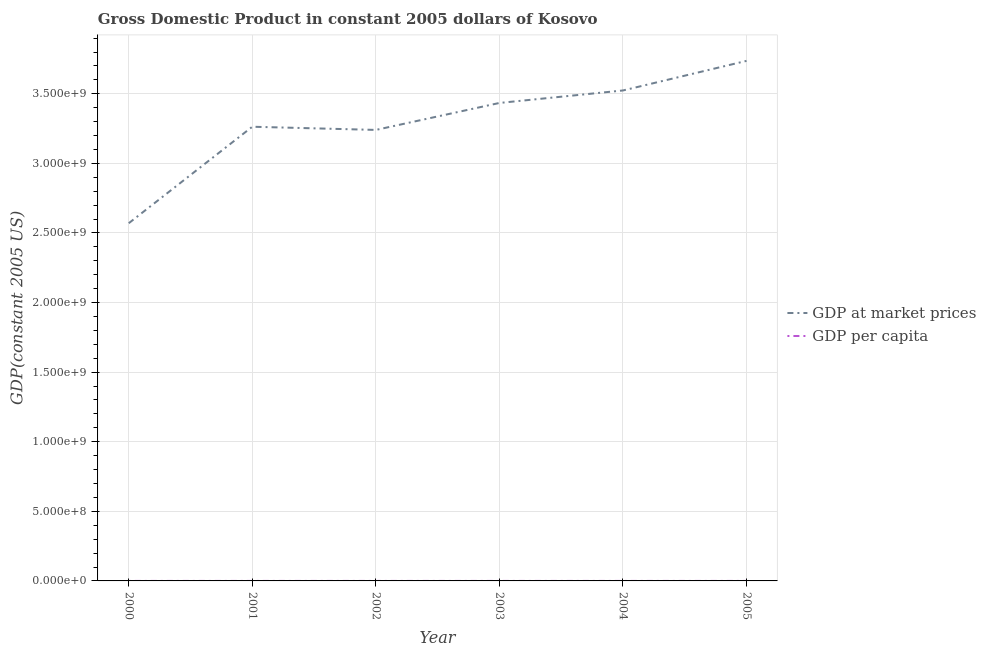How many different coloured lines are there?
Your answer should be very brief. 2. Does the line corresponding to gdp per capita intersect with the line corresponding to gdp at market prices?
Give a very brief answer. No. Is the number of lines equal to the number of legend labels?
Your answer should be very brief. Yes. What is the gdp per capita in 2003?
Keep it short and to the point. 2016.06. Across all years, what is the maximum gdp per capita?
Your response must be concise. 2190.55. Across all years, what is the minimum gdp per capita?
Provide a succinct answer. 1511.83. In which year was the gdp per capita maximum?
Make the answer very short. 2005. What is the total gdp per capita in the graph?
Ensure brevity in your answer.  1.16e+04. What is the difference between the gdp per capita in 2003 and that in 2004?
Your response must be concise. -51.26. What is the difference between the gdp at market prices in 2003 and the gdp per capita in 2000?
Your answer should be compact. 3.43e+09. What is the average gdp at market prices per year?
Offer a very short reply. 3.29e+09. In the year 2004, what is the difference between the gdp at market prices and gdp per capita?
Provide a succinct answer. 3.52e+09. What is the ratio of the gdp per capita in 2000 to that in 2005?
Ensure brevity in your answer.  0.69. Is the difference between the gdp at market prices in 2000 and 2005 greater than the difference between the gdp per capita in 2000 and 2005?
Keep it short and to the point. No. What is the difference between the highest and the second highest gdp at market prices?
Your answer should be compact. 2.13e+08. What is the difference between the highest and the lowest gdp at market prices?
Provide a succinct answer. 1.17e+09. Does the gdp at market prices monotonically increase over the years?
Make the answer very short. No. Is the gdp per capita strictly greater than the gdp at market prices over the years?
Your answer should be very brief. No. How many lines are there?
Give a very brief answer. 2. How many years are there in the graph?
Your response must be concise. 6. What is the difference between two consecutive major ticks on the Y-axis?
Your response must be concise. 5.00e+08. Does the graph contain any zero values?
Ensure brevity in your answer.  No. Does the graph contain grids?
Ensure brevity in your answer.  Yes. Where does the legend appear in the graph?
Offer a terse response. Center right. How are the legend labels stacked?
Your response must be concise. Vertical. What is the title of the graph?
Provide a succinct answer. Gross Domestic Product in constant 2005 dollars of Kosovo. Does "Register a business" appear as one of the legend labels in the graph?
Your response must be concise. No. What is the label or title of the X-axis?
Give a very brief answer. Year. What is the label or title of the Y-axis?
Provide a short and direct response. GDP(constant 2005 US). What is the GDP(constant 2005 US) of GDP at market prices in 2000?
Provide a succinct answer. 2.57e+09. What is the GDP(constant 2005 US) of GDP per capita in 2000?
Keep it short and to the point. 1511.83. What is the GDP(constant 2005 US) in GDP at market prices in 2001?
Give a very brief answer. 3.26e+09. What is the GDP(constant 2005 US) in GDP per capita in 2001?
Provide a succinct answer. 1918.33. What is the GDP(constant 2005 US) in GDP at market prices in 2002?
Your answer should be very brief. 3.24e+09. What is the GDP(constant 2005 US) in GDP per capita in 2002?
Give a very brief answer. 1903.59. What is the GDP(constant 2005 US) in GDP at market prices in 2003?
Provide a succinct answer. 3.43e+09. What is the GDP(constant 2005 US) in GDP per capita in 2003?
Offer a very short reply. 2016.06. What is the GDP(constant 2005 US) of GDP at market prices in 2004?
Offer a very short reply. 3.52e+09. What is the GDP(constant 2005 US) of GDP per capita in 2004?
Make the answer very short. 2067.31. What is the GDP(constant 2005 US) in GDP at market prices in 2005?
Give a very brief answer. 3.74e+09. What is the GDP(constant 2005 US) of GDP per capita in 2005?
Offer a terse response. 2190.55. Across all years, what is the maximum GDP(constant 2005 US) in GDP at market prices?
Provide a succinct answer. 3.74e+09. Across all years, what is the maximum GDP(constant 2005 US) of GDP per capita?
Provide a short and direct response. 2190.55. Across all years, what is the minimum GDP(constant 2005 US) in GDP at market prices?
Your answer should be very brief. 2.57e+09. Across all years, what is the minimum GDP(constant 2005 US) of GDP per capita?
Provide a succinct answer. 1511.83. What is the total GDP(constant 2005 US) of GDP at market prices in the graph?
Give a very brief answer. 1.98e+1. What is the total GDP(constant 2005 US) of GDP per capita in the graph?
Your answer should be compact. 1.16e+04. What is the difference between the GDP(constant 2005 US) of GDP at market prices in 2000 and that in 2001?
Offer a very short reply. -6.93e+08. What is the difference between the GDP(constant 2005 US) of GDP per capita in 2000 and that in 2001?
Your answer should be very brief. -406.5. What is the difference between the GDP(constant 2005 US) of GDP at market prices in 2000 and that in 2002?
Your answer should be compact. -6.70e+08. What is the difference between the GDP(constant 2005 US) of GDP per capita in 2000 and that in 2002?
Your answer should be very brief. -391.76. What is the difference between the GDP(constant 2005 US) of GDP at market prices in 2000 and that in 2003?
Provide a succinct answer. -8.64e+08. What is the difference between the GDP(constant 2005 US) of GDP per capita in 2000 and that in 2003?
Your answer should be very brief. -504.23. What is the difference between the GDP(constant 2005 US) of GDP at market prices in 2000 and that in 2004?
Your response must be concise. -9.54e+08. What is the difference between the GDP(constant 2005 US) of GDP per capita in 2000 and that in 2004?
Give a very brief answer. -555.48. What is the difference between the GDP(constant 2005 US) in GDP at market prices in 2000 and that in 2005?
Your response must be concise. -1.17e+09. What is the difference between the GDP(constant 2005 US) of GDP per capita in 2000 and that in 2005?
Offer a very short reply. -678.72. What is the difference between the GDP(constant 2005 US) in GDP at market prices in 2001 and that in 2002?
Provide a short and direct response. 2.29e+07. What is the difference between the GDP(constant 2005 US) of GDP per capita in 2001 and that in 2002?
Offer a terse response. 14.74. What is the difference between the GDP(constant 2005 US) of GDP at market prices in 2001 and that in 2003?
Make the answer very short. -1.71e+08. What is the difference between the GDP(constant 2005 US) in GDP per capita in 2001 and that in 2003?
Make the answer very short. -97.73. What is the difference between the GDP(constant 2005 US) of GDP at market prices in 2001 and that in 2004?
Offer a terse response. -2.61e+08. What is the difference between the GDP(constant 2005 US) of GDP per capita in 2001 and that in 2004?
Make the answer very short. -148.99. What is the difference between the GDP(constant 2005 US) of GDP at market prices in 2001 and that in 2005?
Offer a terse response. -4.73e+08. What is the difference between the GDP(constant 2005 US) in GDP per capita in 2001 and that in 2005?
Your answer should be very brief. -272.22. What is the difference between the GDP(constant 2005 US) in GDP at market prices in 2002 and that in 2003?
Your response must be concise. -1.94e+08. What is the difference between the GDP(constant 2005 US) in GDP per capita in 2002 and that in 2003?
Your answer should be very brief. -112.47. What is the difference between the GDP(constant 2005 US) in GDP at market prices in 2002 and that in 2004?
Provide a succinct answer. -2.83e+08. What is the difference between the GDP(constant 2005 US) of GDP per capita in 2002 and that in 2004?
Your answer should be very brief. -163.73. What is the difference between the GDP(constant 2005 US) of GDP at market prices in 2002 and that in 2005?
Offer a very short reply. -4.96e+08. What is the difference between the GDP(constant 2005 US) of GDP per capita in 2002 and that in 2005?
Offer a terse response. -286.96. What is the difference between the GDP(constant 2005 US) of GDP at market prices in 2003 and that in 2004?
Ensure brevity in your answer.  -8.97e+07. What is the difference between the GDP(constant 2005 US) of GDP per capita in 2003 and that in 2004?
Offer a very short reply. -51.26. What is the difference between the GDP(constant 2005 US) of GDP at market prices in 2003 and that in 2005?
Make the answer very short. -3.02e+08. What is the difference between the GDP(constant 2005 US) in GDP per capita in 2003 and that in 2005?
Give a very brief answer. -174.5. What is the difference between the GDP(constant 2005 US) in GDP at market prices in 2004 and that in 2005?
Make the answer very short. -2.13e+08. What is the difference between the GDP(constant 2005 US) in GDP per capita in 2004 and that in 2005?
Your answer should be very brief. -123.24. What is the difference between the GDP(constant 2005 US) of GDP at market prices in 2000 and the GDP(constant 2005 US) of GDP per capita in 2001?
Offer a terse response. 2.57e+09. What is the difference between the GDP(constant 2005 US) of GDP at market prices in 2000 and the GDP(constant 2005 US) of GDP per capita in 2002?
Your answer should be very brief. 2.57e+09. What is the difference between the GDP(constant 2005 US) of GDP at market prices in 2000 and the GDP(constant 2005 US) of GDP per capita in 2003?
Offer a very short reply. 2.57e+09. What is the difference between the GDP(constant 2005 US) of GDP at market prices in 2000 and the GDP(constant 2005 US) of GDP per capita in 2004?
Give a very brief answer. 2.57e+09. What is the difference between the GDP(constant 2005 US) in GDP at market prices in 2000 and the GDP(constant 2005 US) in GDP per capita in 2005?
Give a very brief answer. 2.57e+09. What is the difference between the GDP(constant 2005 US) in GDP at market prices in 2001 and the GDP(constant 2005 US) in GDP per capita in 2002?
Offer a terse response. 3.26e+09. What is the difference between the GDP(constant 2005 US) in GDP at market prices in 2001 and the GDP(constant 2005 US) in GDP per capita in 2003?
Your response must be concise. 3.26e+09. What is the difference between the GDP(constant 2005 US) of GDP at market prices in 2001 and the GDP(constant 2005 US) of GDP per capita in 2004?
Ensure brevity in your answer.  3.26e+09. What is the difference between the GDP(constant 2005 US) in GDP at market prices in 2001 and the GDP(constant 2005 US) in GDP per capita in 2005?
Your response must be concise. 3.26e+09. What is the difference between the GDP(constant 2005 US) in GDP at market prices in 2002 and the GDP(constant 2005 US) in GDP per capita in 2003?
Ensure brevity in your answer.  3.24e+09. What is the difference between the GDP(constant 2005 US) in GDP at market prices in 2002 and the GDP(constant 2005 US) in GDP per capita in 2004?
Your answer should be compact. 3.24e+09. What is the difference between the GDP(constant 2005 US) of GDP at market prices in 2002 and the GDP(constant 2005 US) of GDP per capita in 2005?
Provide a succinct answer. 3.24e+09. What is the difference between the GDP(constant 2005 US) of GDP at market prices in 2003 and the GDP(constant 2005 US) of GDP per capita in 2004?
Keep it short and to the point. 3.43e+09. What is the difference between the GDP(constant 2005 US) of GDP at market prices in 2003 and the GDP(constant 2005 US) of GDP per capita in 2005?
Your response must be concise. 3.43e+09. What is the difference between the GDP(constant 2005 US) in GDP at market prices in 2004 and the GDP(constant 2005 US) in GDP per capita in 2005?
Offer a terse response. 3.52e+09. What is the average GDP(constant 2005 US) in GDP at market prices per year?
Your answer should be compact. 3.29e+09. What is the average GDP(constant 2005 US) of GDP per capita per year?
Offer a very short reply. 1934.61. In the year 2000, what is the difference between the GDP(constant 2005 US) of GDP at market prices and GDP(constant 2005 US) of GDP per capita?
Offer a terse response. 2.57e+09. In the year 2001, what is the difference between the GDP(constant 2005 US) in GDP at market prices and GDP(constant 2005 US) in GDP per capita?
Offer a very short reply. 3.26e+09. In the year 2002, what is the difference between the GDP(constant 2005 US) in GDP at market prices and GDP(constant 2005 US) in GDP per capita?
Provide a succinct answer. 3.24e+09. In the year 2003, what is the difference between the GDP(constant 2005 US) in GDP at market prices and GDP(constant 2005 US) in GDP per capita?
Give a very brief answer. 3.43e+09. In the year 2004, what is the difference between the GDP(constant 2005 US) in GDP at market prices and GDP(constant 2005 US) in GDP per capita?
Keep it short and to the point. 3.52e+09. In the year 2005, what is the difference between the GDP(constant 2005 US) in GDP at market prices and GDP(constant 2005 US) in GDP per capita?
Keep it short and to the point. 3.74e+09. What is the ratio of the GDP(constant 2005 US) in GDP at market prices in 2000 to that in 2001?
Your answer should be very brief. 0.79. What is the ratio of the GDP(constant 2005 US) of GDP per capita in 2000 to that in 2001?
Your answer should be very brief. 0.79. What is the ratio of the GDP(constant 2005 US) in GDP at market prices in 2000 to that in 2002?
Ensure brevity in your answer.  0.79. What is the ratio of the GDP(constant 2005 US) of GDP per capita in 2000 to that in 2002?
Your response must be concise. 0.79. What is the ratio of the GDP(constant 2005 US) in GDP at market prices in 2000 to that in 2003?
Your answer should be very brief. 0.75. What is the ratio of the GDP(constant 2005 US) of GDP per capita in 2000 to that in 2003?
Ensure brevity in your answer.  0.75. What is the ratio of the GDP(constant 2005 US) of GDP at market prices in 2000 to that in 2004?
Your answer should be very brief. 0.73. What is the ratio of the GDP(constant 2005 US) in GDP per capita in 2000 to that in 2004?
Give a very brief answer. 0.73. What is the ratio of the GDP(constant 2005 US) in GDP at market prices in 2000 to that in 2005?
Ensure brevity in your answer.  0.69. What is the ratio of the GDP(constant 2005 US) in GDP per capita in 2000 to that in 2005?
Provide a succinct answer. 0.69. What is the ratio of the GDP(constant 2005 US) of GDP at market prices in 2001 to that in 2002?
Ensure brevity in your answer.  1.01. What is the ratio of the GDP(constant 2005 US) in GDP per capita in 2001 to that in 2002?
Keep it short and to the point. 1.01. What is the ratio of the GDP(constant 2005 US) in GDP at market prices in 2001 to that in 2003?
Provide a short and direct response. 0.95. What is the ratio of the GDP(constant 2005 US) of GDP per capita in 2001 to that in 2003?
Ensure brevity in your answer.  0.95. What is the ratio of the GDP(constant 2005 US) of GDP at market prices in 2001 to that in 2004?
Offer a terse response. 0.93. What is the ratio of the GDP(constant 2005 US) in GDP per capita in 2001 to that in 2004?
Your response must be concise. 0.93. What is the ratio of the GDP(constant 2005 US) in GDP at market prices in 2001 to that in 2005?
Offer a very short reply. 0.87. What is the ratio of the GDP(constant 2005 US) in GDP per capita in 2001 to that in 2005?
Offer a very short reply. 0.88. What is the ratio of the GDP(constant 2005 US) of GDP at market prices in 2002 to that in 2003?
Your response must be concise. 0.94. What is the ratio of the GDP(constant 2005 US) of GDP per capita in 2002 to that in 2003?
Keep it short and to the point. 0.94. What is the ratio of the GDP(constant 2005 US) of GDP at market prices in 2002 to that in 2004?
Your answer should be compact. 0.92. What is the ratio of the GDP(constant 2005 US) in GDP per capita in 2002 to that in 2004?
Provide a succinct answer. 0.92. What is the ratio of the GDP(constant 2005 US) in GDP at market prices in 2002 to that in 2005?
Ensure brevity in your answer.  0.87. What is the ratio of the GDP(constant 2005 US) in GDP per capita in 2002 to that in 2005?
Your answer should be compact. 0.87. What is the ratio of the GDP(constant 2005 US) of GDP at market prices in 2003 to that in 2004?
Your answer should be very brief. 0.97. What is the ratio of the GDP(constant 2005 US) in GDP per capita in 2003 to that in 2004?
Provide a succinct answer. 0.98. What is the ratio of the GDP(constant 2005 US) in GDP at market prices in 2003 to that in 2005?
Your response must be concise. 0.92. What is the ratio of the GDP(constant 2005 US) of GDP per capita in 2003 to that in 2005?
Make the answer very short. 0.92. What is the ratio of the GDP(constant 2005 US) of GDP at market prices in 2004 to that in 2005?
Your response must be concise. 0.94. What is the ratio of the GDP(constant 2005 US) of GDP per capita in 2004 to that in 2005?
Offer a very short reply. 0.94. What is the difference between the highest and the second highest GDP(constant 2005 US) in GDP at market prices?
Keep it short and to the point. 2.13e+08. What is the difference between the highest and the second highest GDP(constant 2005 US) in GDP per capita?
Offer a terse response. 123.24. What is the difference between the highest and the lowest GDP(constant 2005 US) of GDP at market prices?
Give a very brief answer. 1.17e+09. What is the difference between the highest and the lowest GDP(constant 2005 US) of GDP per capita?
Provide a short and direct response. 678.72. 